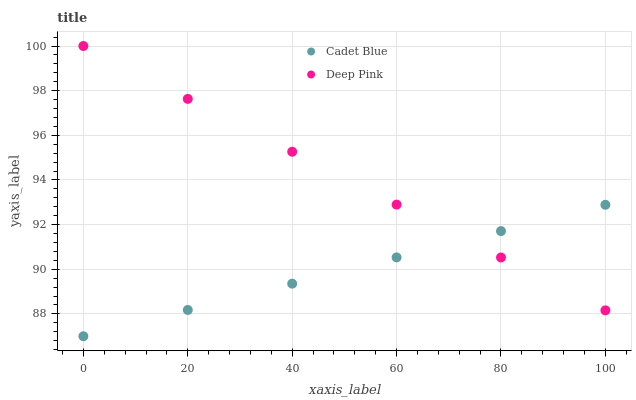Does Cadet Blue have the minimum area under the curve?
Answer yes or no. Yes. Does Deep Pink have the maximum area under the curve?
Answer yes or no. Yes. Does Deep Pink have the minimum area under the curve?
Answer yes or no. No. Is Deep Pink the smoothest?
Answer yes or no. Yes. Is Cadet Blue the roughest?
Answer yes or no. Yes. Is Deep Pink the roughest?
Answer yes or no. No. Does Cadet Blue have the lowest value?
Answer yes or no. Yes. Does Deep Pink have the lowest value?
Answer yes or no. No. Does Deep Pink have the highest value?
Answer yes or no. Yes. Does Cadet Blue intersect Deep Pink?
Answer yes or no. Yes. Is Cadet Blue less than Deep Pink?
Answer yes or no. No. Is Cadet Blue greater than Deep Pink?
Answer yes or no. No. 